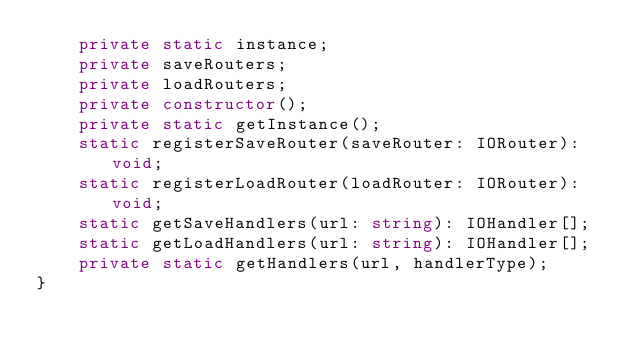Convert code to text. <code><loc_0><loc_0><loc_500><loc_500><_TypeScript_>    private static instance;
    private saveRouters;
    private loadRouters;
    private constructor();
    private static getInstance();
    static registerSaveRouter(saveRouter: IORouter): void;
    static registerLoadRouter(loadRouter: IORouter): void;
    static getSaveHandlers(url: string): IOHandler[];
    static getLoadHandlers(url: string): IOHandler[];
    private static getHandlers(url, handlerType);
}
</code> 